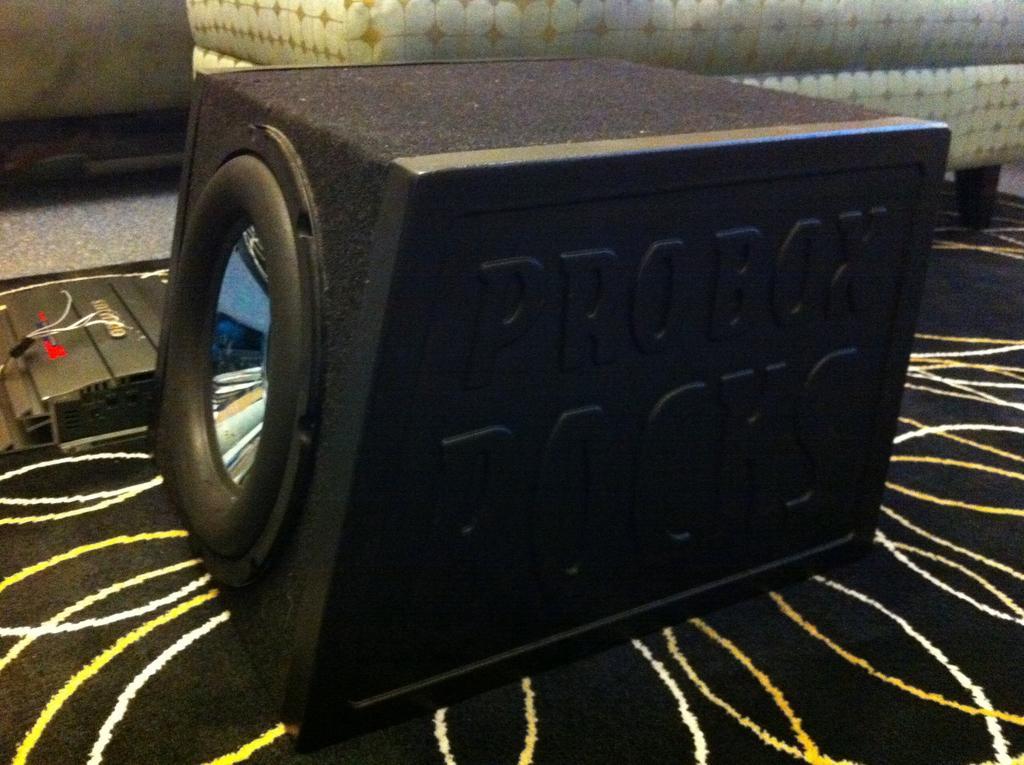Describe this image in one or two sentences. in the picture there was a sound box present in the table. 